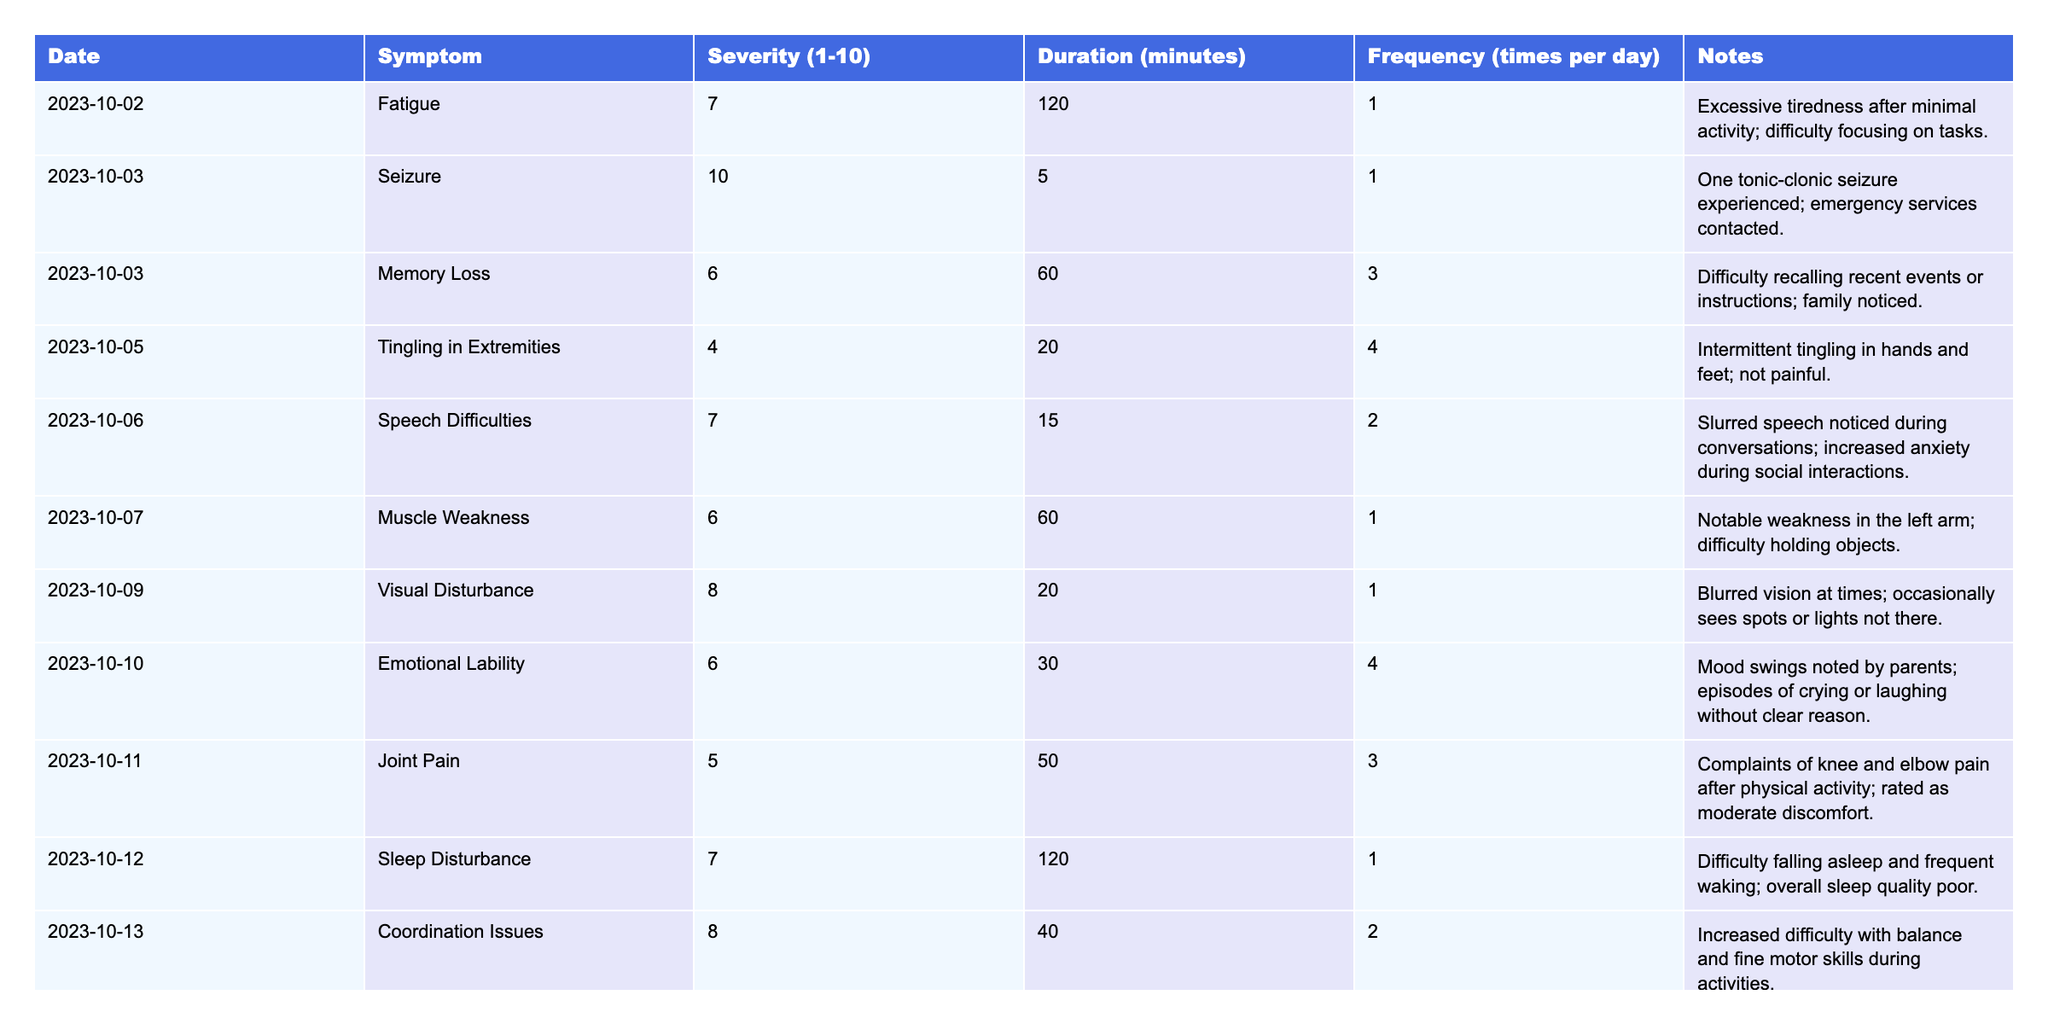What symptom had the highest severity rating? The table shows severity ratings for various symptoms. The highest severity rating is 10, which corresponds to the seizure symptom on 2023-10-03.
Answer: Seizure What is the total number of times the child experienced memory loss? The frequency for memory loss is recorded as 3 times per day on 2023-10-03. Therefore, the total is 3.
Answer: 3 On which date did the child experience sleep disturbances? The table lists a sleep disturbance on 2023-10-12. This date specifically mentions difficulty falling asleep and waking frequently.
Answer: 2023-10-12 How many different symptoms are recorded in the table? The table lists a total of 10 different symptoms. Counting each unique symptom from the 'Symptom' column provides this total.
Answer: 10 What is the average severity score for symptoms related to emotional conditions? The emotional lability has a severity score of 6, and fatigue is not typically classified as emotional, so this is the only score to consider. Thus, the average is 6.
Answer: 6 Was there any day when the child experienced seizures more than once? The table indicates that seizures occurred only once on 2023-10-03. Thus, there were no days with multiple seizures.
Answer: No How many more times per day does the child experience coordination issues compared to joint pain? Coordination issues occurred 2 times per day, while joint pain occurred 3 times per day. The difference is 3 minus 2, which equals 1.
Answer: 1 What symptoms were experienced on the same day as emotional lability? Emotional lability occurred on 2023-10-10, where the child also experienced a phonophobia. Checking the table confirms this pairing.
Answer: Phonophobia What is the total duration for symptoms reported as having a severity of 7 or higher? The total durations for severity ratings of 7 or higher are: fatigue (120 minutes), seizure (5 minutes), sleep disturbance (120 minutes), speech difficulties (15 minutes), emotional lability (30 minutes), coordination issues (40 minutes). Summing these gives: 120 + 5 + 120 + 15 + 30 + 40 = 330 minutes.
Answer: 330 minutes Was there any mention of visual disturbances? The table records a symptom of visual disturbance with a severity of 8 on 2023-10-09, confirming the presence of this symptom.
Answer: Yes 